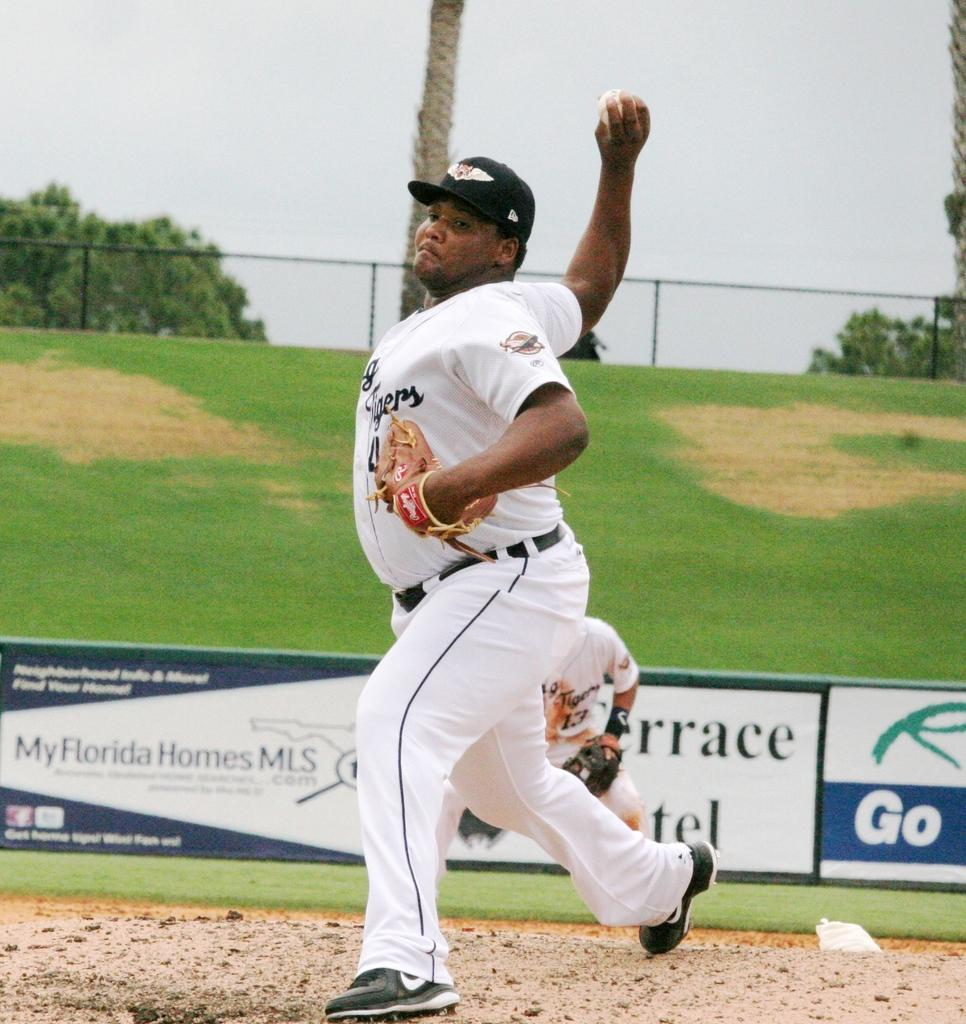<image>
Offer a succinct explanation of the picture presented. A man in a baseball uniform is about to pitch while at a filed with a advertisement that says My Florida Homes MLS 